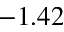Convert formula to latex. <formula><loc_0><loc_0><loc_500><loc_500>- 1 . 4 2</formula> 